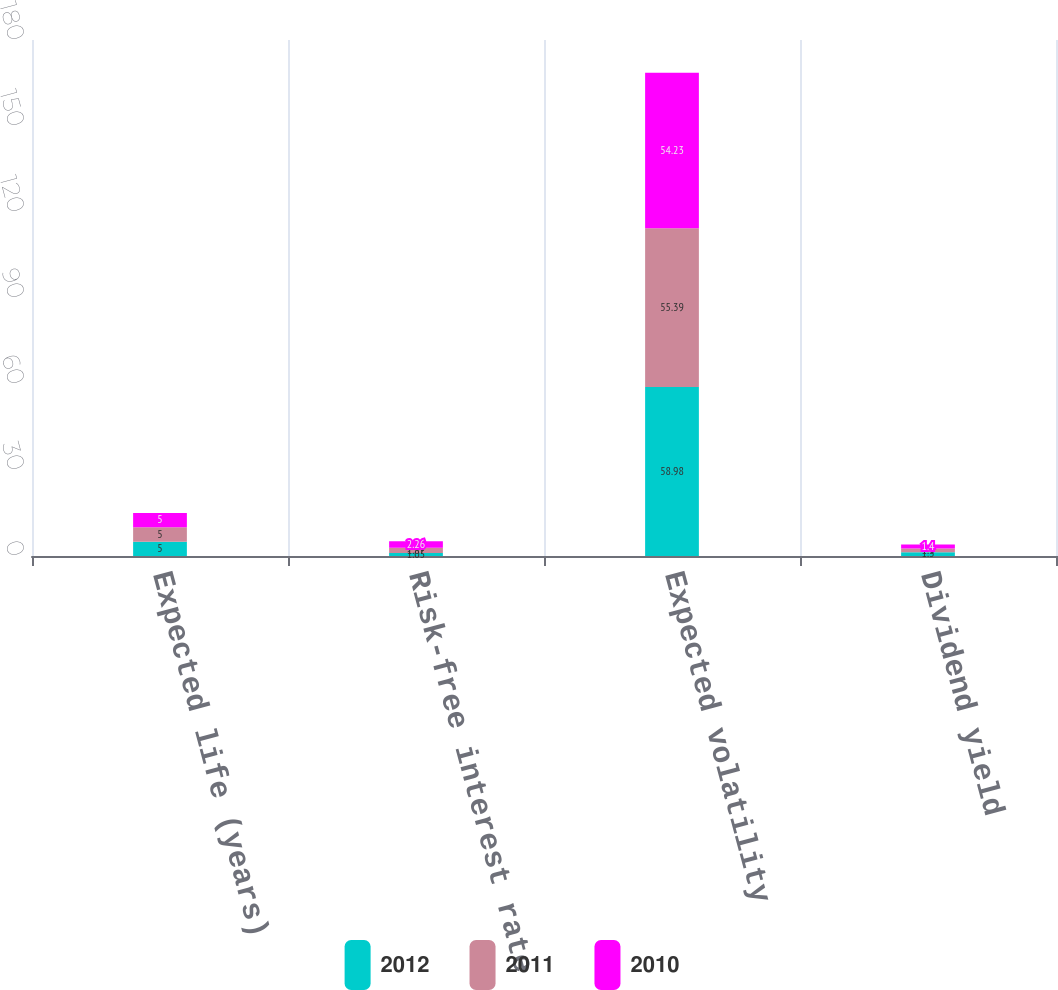Convert chart. <chart><loc_0><loc_0><loc_500><loc_500><stacked_bar_chart><ecel><fcel>Expected life (years)<fcel>Risk-free interest rate<fcel>Expected volatility<fcel>Dividend yield<nl><fcel>2012<fcel>5<fcel>1.05<fcel>58.98<fcel>1.3<nl><fcel>2011<fcel>5<fcel>1.87<fcel>55.39<fcel>1.3<nl><fcel>2010<fcel>5<fcel>2.26<fcel>54.23<fcel>1.4<nl></chart> 